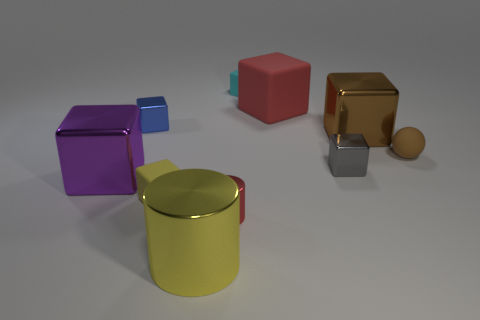There is a object that is the same color as the tiny matte sphere; what shape is it?
Offer a terse response. Cube. Does the brown metal cube have the same size as the yellow cylinder?
Offer a terse response. Yes. What is the material of the cyan cube?
Offer a very short reply. Rubber. There is a small sphere that is made of the same material as the red cube; what color is it?
Offer a very short reply. Brown. Is the material of the yellow cylinder the same as the block behind the big rubber thing?
Your response must be concise. No. How many small blue blocks have the same material as the small brown thing?
Provide a succinct answer. 0. The red rubber thing that is on the right side of the blue block has what shape?
Your answer should be very brief. Cube. Are the brown thing that is left of the tiny brown rubber sphere and the red thing left of the cyan matte cube made of the same material?
Give a very brief answer. Yes. Is there a large purple shiny thing that has the same shape as the tiny yellow rubber object?
Provide a short and direct response. Yes. What number of things are large things that are behind the small yellow rubber thing or green rubber cylinders?
Make the answer very short. 3. 